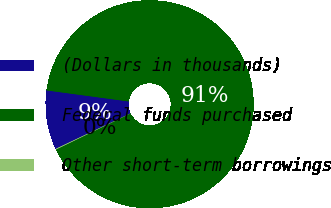<chart> <loc_0><loc_0><loc_500><loc_500><pie_chart><fcel>(Dollars in thousands)<fcel>Federal funds purchased<fcel>Other short-term borrowings<nl><fcel>9.18%<fcel>90.69%<fcel>0.12%<nl></chart> 